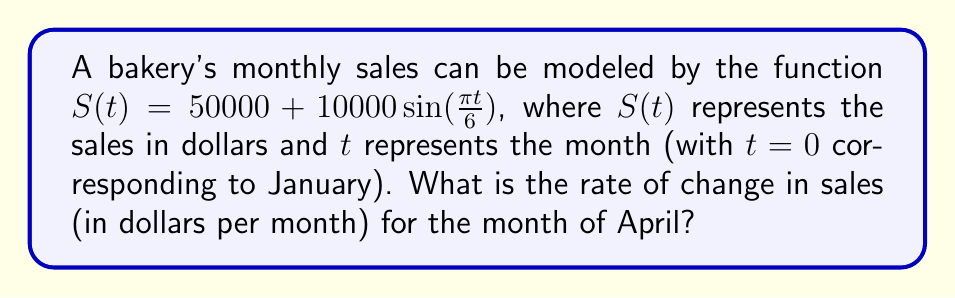Could you help me with this problem? To solve this problem, we need to follow these steps:

1) First, we need to find the derivative of the sales function $S(t)$. 
   $$S'(t) = 10000 \cdot \frac{\pi}{6} \cos(\frac{\pi t}{6})$$

2) April is the 4th month, so $t = 3$ (remember, January is $t = 0$).

3) Now, we substitute $t = 3$ into our derivative function:
   $$S'(3) = 10000 \cdot \frac{\pi}{6} \cos(\frac{\pi \cdot 3}{6})$$

4) Simplify:
   $$S'(3) = 10000 \cdot \frac{\pi}{6} \cos(\frac{\pi}{2})$$

5) We know that $\cos(\frac{\pi}{2}) = 0$, so:
   $$S'(3) = 10000 \cdot \frac{\pi}{6} \cdot 0 = 0$$

Therefore, the rate of change in sales for the month of April is $0 dollars per month.
Answer: $0 per month 